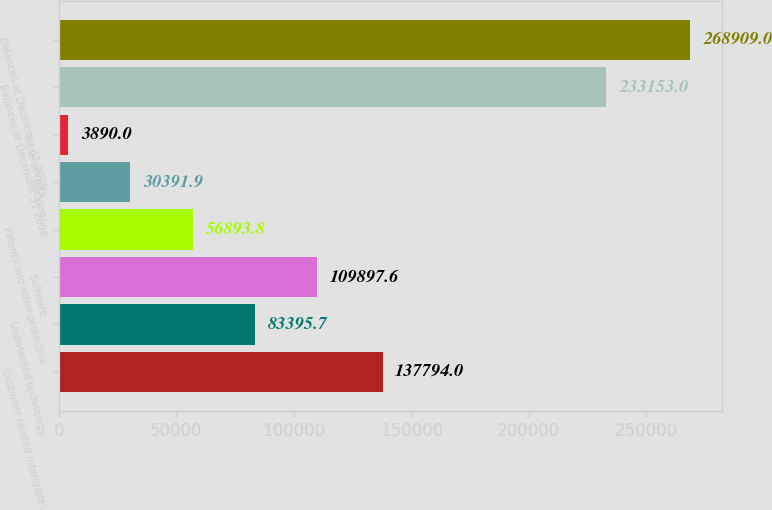<chart> <loc_0><loc_0><loc_500><loc_500><bar_chart><fcel>Customer related intangibles<fcel>Unpatented technology<fcel>Software<fcel>Patents and other protective<fcel>Backlog<fcel>Trade secrets<fcel>Balances at December 31 2008<fcel>Balances at December 31 2009<nl><fcel>137794<fcel>83395.7<fcel>109898<fcel>56893.8<fcel>30391.9<fcel>3890<fcel>233153<fcel>268909<nl></chart> 